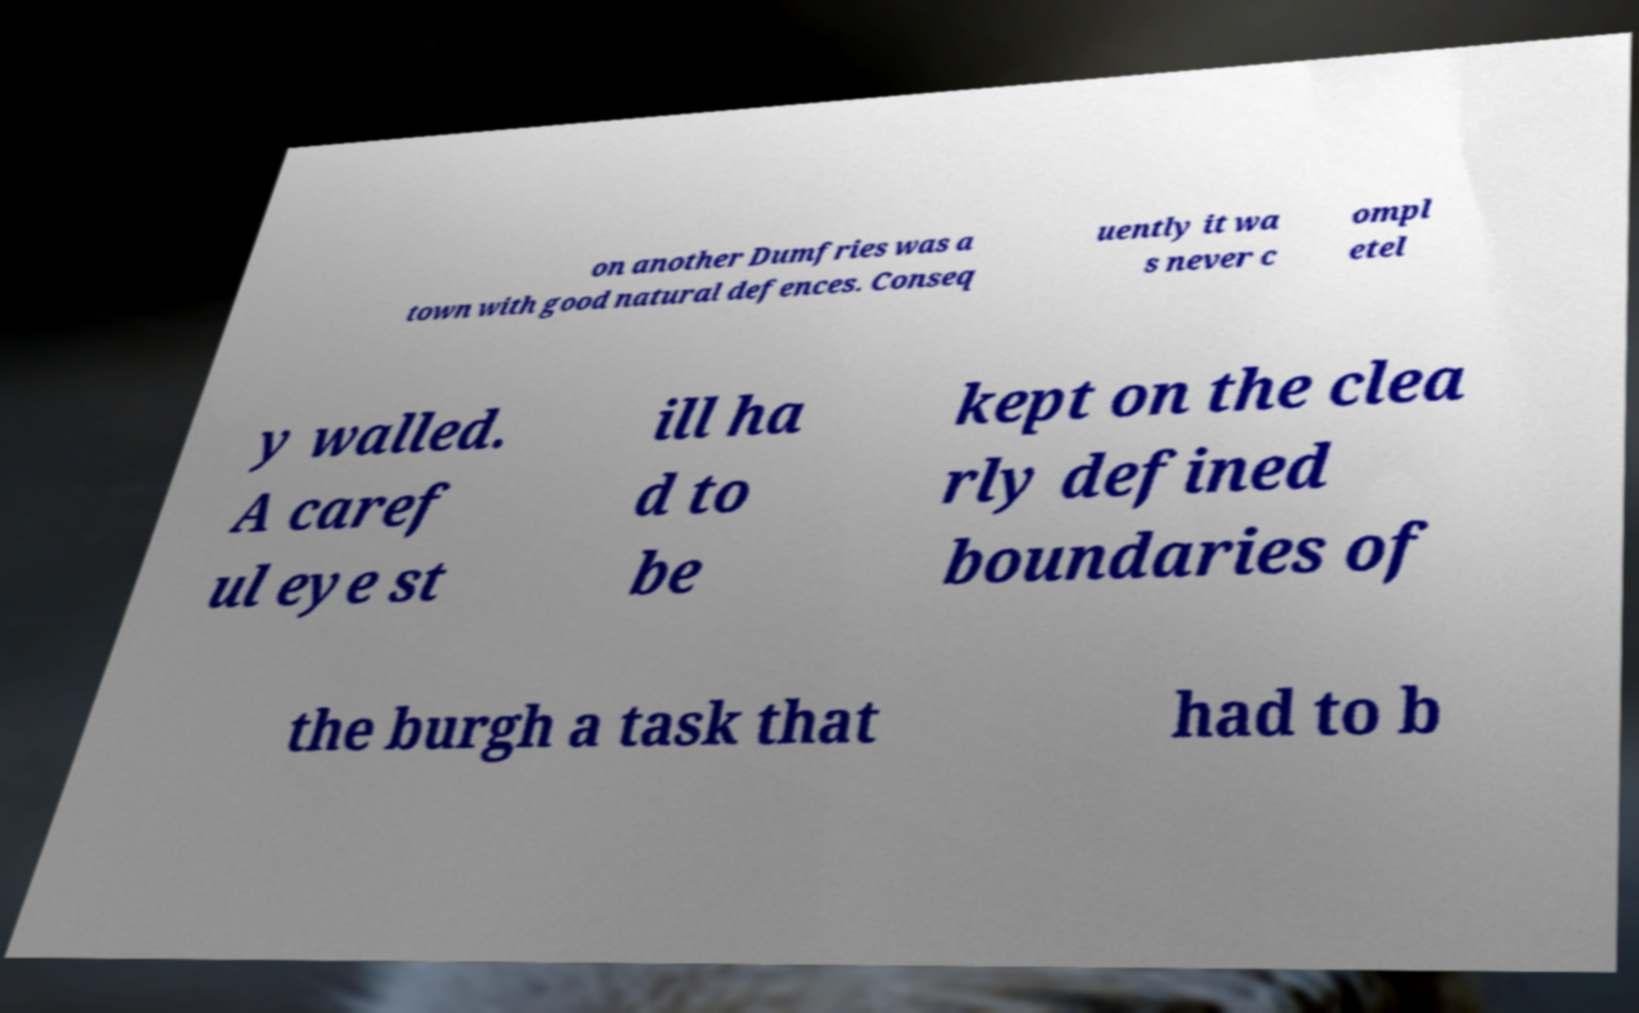Can you accurately transcribe the text from the provided image for me? on another Dumfries was a town with good natural defences. Conseq uently it wa s never c ompl etel y walled. A caref ul eye st ill ha d to be kept on the clea rly defined boundaries of the burgh a task that had to b 